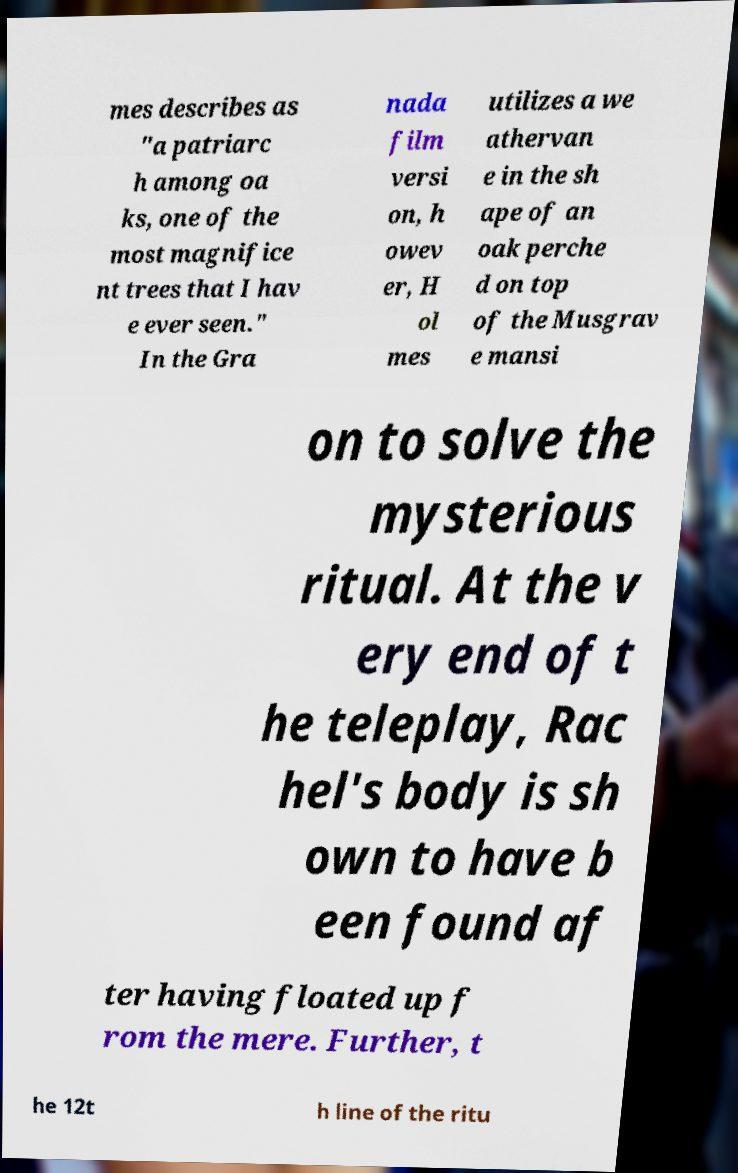What messages or text are displayed in this image? I need them in a readable, typed format. mes describes as "a patriarc h among oa ks, one of the most magnifice nt trees that I hav e ever seen." In the Gra nada film versi on, h owev er, H ol mes utilizes a we athervan e in the sh ape of an oak perche d on top of the Musgrav e mansi on to solve the mysterious ritual. At the v ery end of t he teleplay, Rac hel's body is sh own to have b een found af ter having floated up f rom the mere. Further, t he 12t h line of the ritu 